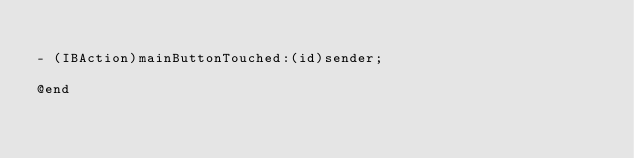Convert code to text. <code><loc_0><loc_0><loc_500><loc_500><_C_>
- (IBAction)mainButtonTouched:(id)sender;

@end
</code> 